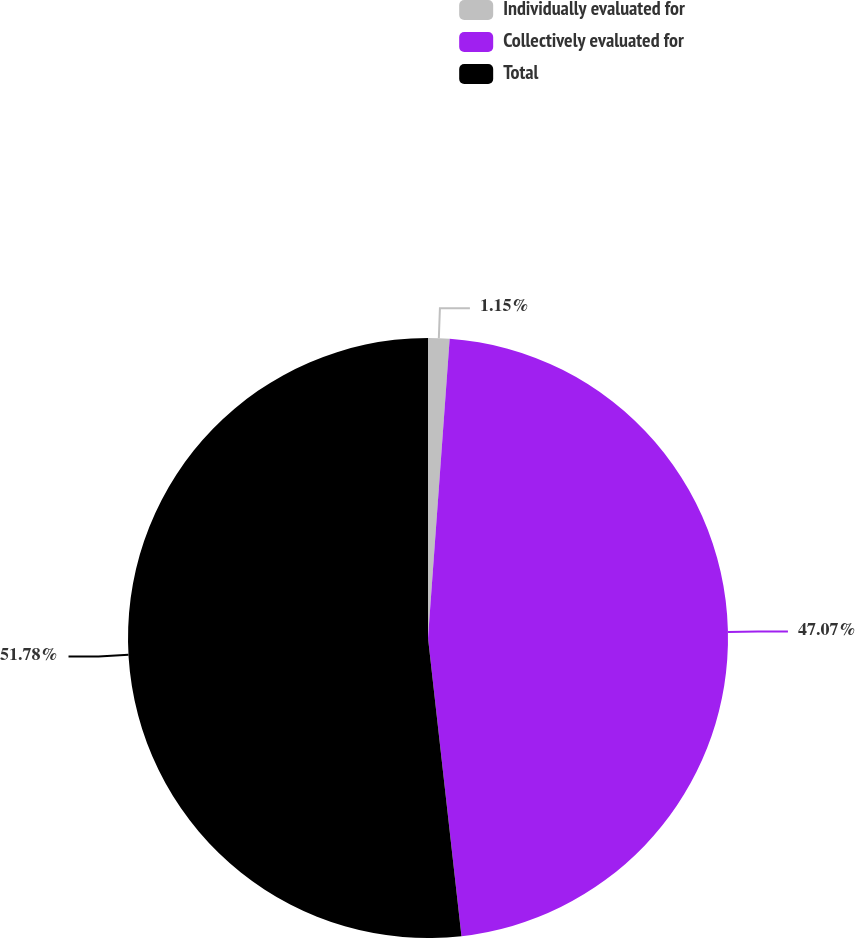<chart> <loc_0><loc_0><loc_500><loc_500><pie_chart><fcel>Individually evaluated for<fcel>Collectively evaluated for<fcel>Total<nl><fcel>1.15%<fcel>47.07%<fcel>51.78%<nl></chart> 